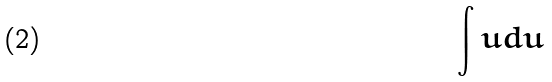Convert formula to latex. <formula><loc_0><loc_0><loc_500><loc_500>\int u d u</formula> 